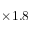<formula> <loc_0><loc_0><loc_500><loc_500>\times 1 . 8</formula> 